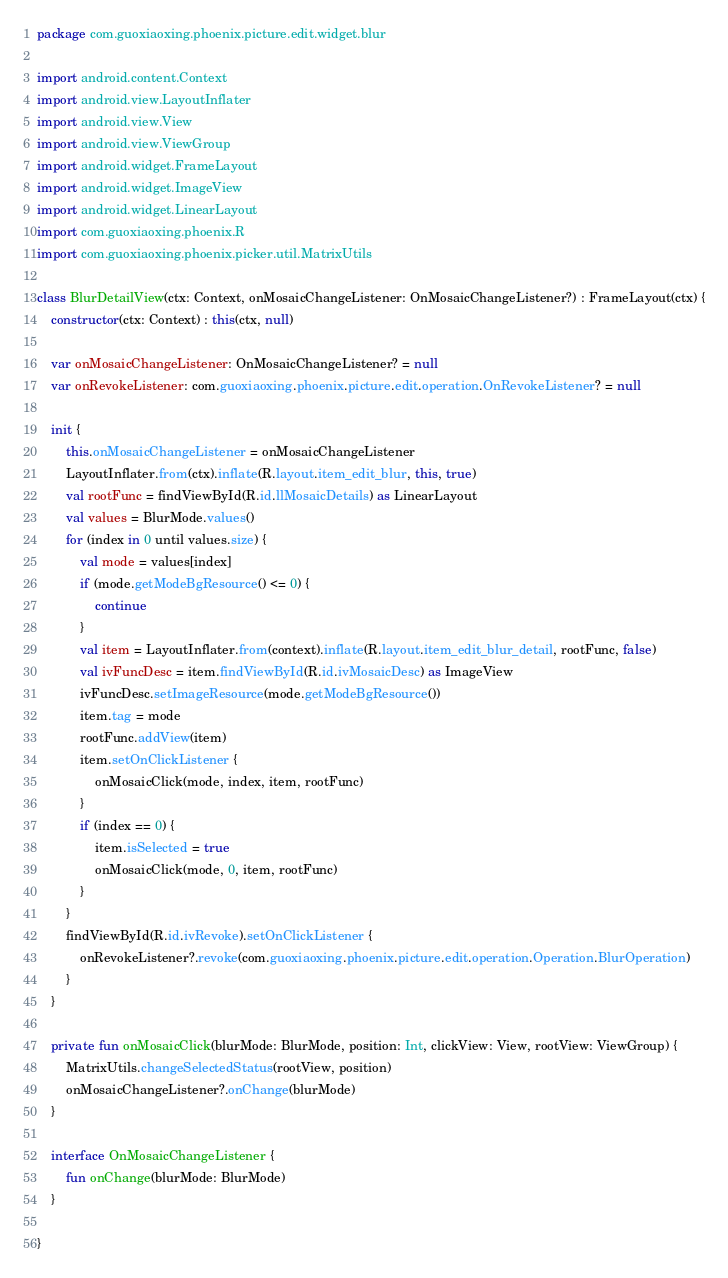<code> <loc_0><loc_0><loc_500><loc_500><_Kotlin_>package com.guoxiaoxing.phoenix.picture.edit.widget.blur

import android.content.Context
import android.view.LayoutInflater
import android.view.View
import android.view.ViewGroup
import android.widget.FrameLayout
import android.widget.ImageView
import android.widget.LinearLayout
import com.guoxiaoxing.phoenix.R
import com.guoxiaoxing.phoenix.picker.util.MatrixUtils

class BlurDetailView(ctx: Context, onMosaicChangeListener: OnMosaicChangeListener?) : FrameLayout(ctx) {
    constructor(ctx: Context) : this(ctx, null)

    var onMosaicChangeListener: OnMosaicChangeListener? = null
    var onRevokeListener: com.guoxiaoxing.phoenix.picture.edit.operation.OnRevokeListener? = null

    init {
        this.onMosaicChangeListener = onMosaicChangeListener
        LayoutInflater.from(ctx).inflate(R.layout.item_edit_blur, this, true)
        val rootFunc = findViewById(R.id.llMosaicDetails) as LinearLayout
        val values = BlurMode.values()
        for (index in 0 until values.size) {
            val mode = values[index]
            if (mode.getModeBgResource() <= 0) {
                continue
            }
            val item = LayoutInflater.from(context).inflate(R.layout.item_edit_blur_detail, rootFunc, false)
            val ivFuncDesc = item.findViewById(R.id.ivMosaicDesc) as ImageView
            ivFuncDesc.setImageResource(mode.getModeBgResource())
            item.tag = mode
            rootFunc.addView(item)
            item.setOnClickListener {
                onMosaicClick(mode, index, item, rootFunc)
            }
            if (index == 0) {
                item.isSelected = true
                onMosaicClick(mode, 0, item, rootFunc)
            }
        }
        findViewById(R.id.ivRevoke).setOnClickListener {
            onRevokeListener?.revoke(com.guoxiaoxing.phoenix.picture.edit.operation.Operation.BlurOperation)
        }
    }

    private fun onMosaicClick(blurMode: BlurMode, position: Int, clickView: View, rootView: ViewGroup) {
        MatrixUtils.changeSelectedStatus(rootView, position)
        onMosaicChangeListener?.onChange(blurMode)
    }

    interface OnMosaicChangeListener {
        fun onChange(blurMode: BlurMode)
    }

}</code> 